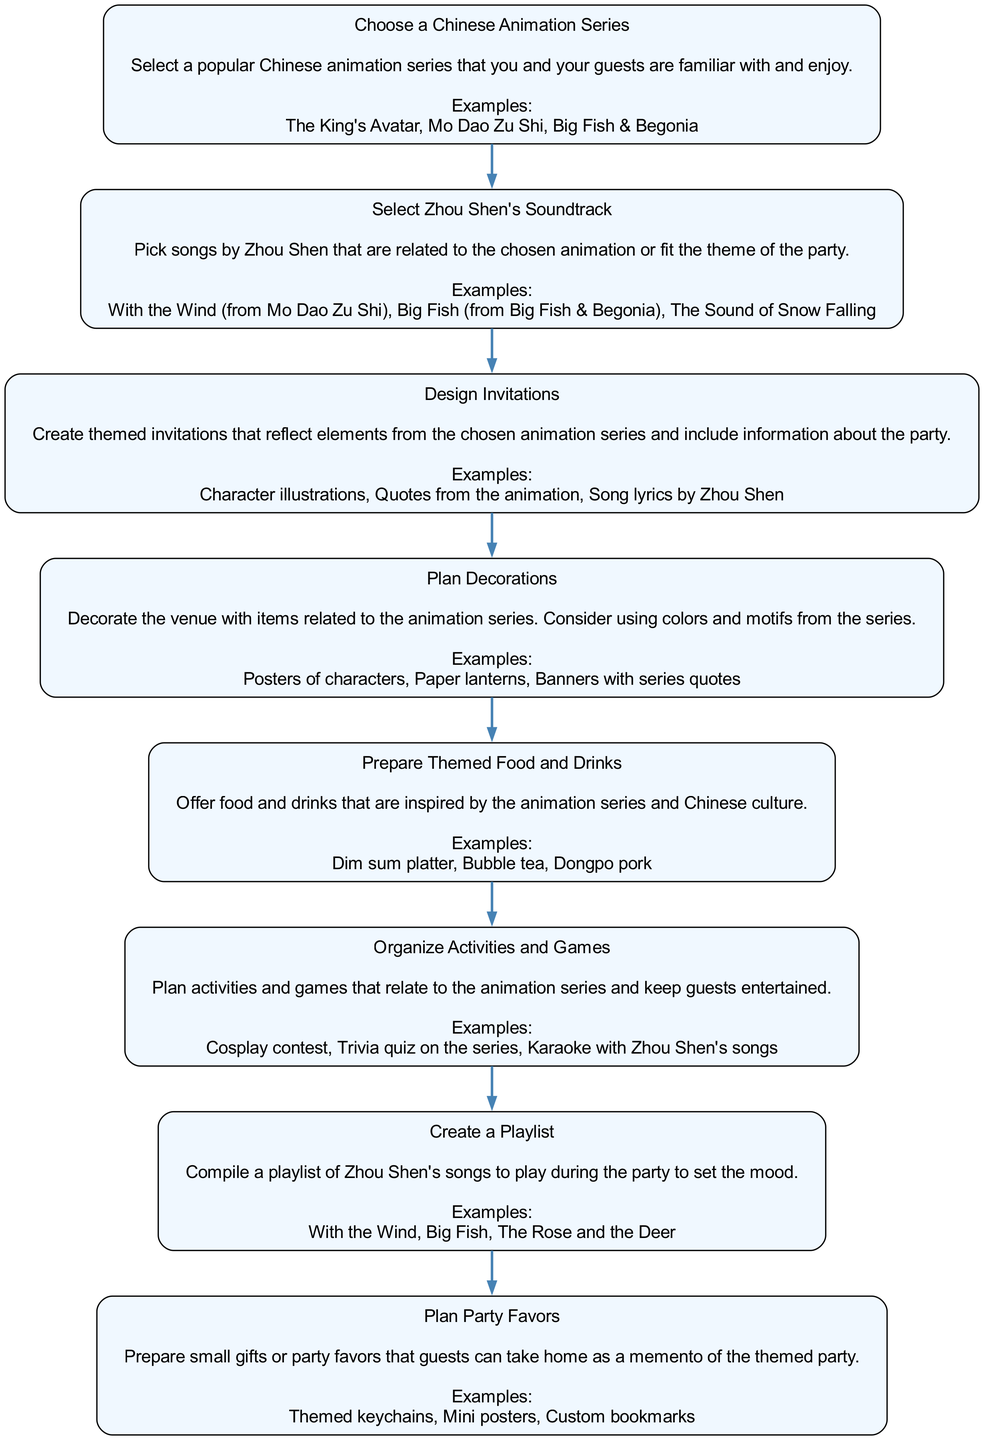What is the first step in planning the themed party? The diagram indicates that the first step is "Choose a Chinese Animation Series," which is the initial action to take when starting the planning process.
Answer: Choose a Chinese Animation Series How many nodes are present in the diagram? The diagram contains a total of eight distinct steps, each represented as a node for planning the party.
Answer: 8 What is the title of the fourth node? The fourth node in the sequence is titled "Plan Decorations," which relates to how to visually arrange the party space in line with the chosen theme.
Answer: Plan Decorations What is the last step in the flow chart? The diagram shows that the final action to complete when planning the party is "Plan Party Favors," which suggests that party favors are one of the last things to prepare.
Answer: Plan Party Favors Which node includes organizing activities? The node labeled "Organize Activities and Games" specifically deals with planning interactive elements for the party, indicating when to include fun and entertainment.
Answer: Organize Activities and Games What type of examples does the third node provide? The third node gives examples that relate to the design of invitations, specifically mentioning "Character illustrations," "Quotes from the animation," and "Song lyrics by Zhou Shen."
Answer: Character illustrations, Quotes from the animation, Song lyrics by Zhou Shen How are Zhou Shen's songs incorporated according to the diagram? Zhou Shen's songs are incorporated as part of the "Select Zhou Shen's Soundtrack" step, ensuring that the chosen music aligns with the overall theme of the selected animation.
Answer: Select Zhou Shen's Soundtrack Which two nodes are connected to the "Prepare Themed Food and Drinks"? The "Prepare Themed Food and Drinks" node is preceded by "Plan Decorations," and it connects to the next step, "Organize Activities and Games," helping to illustrate the flow of planning.
Answer: Plan Decorations, Organize Activities and Games 